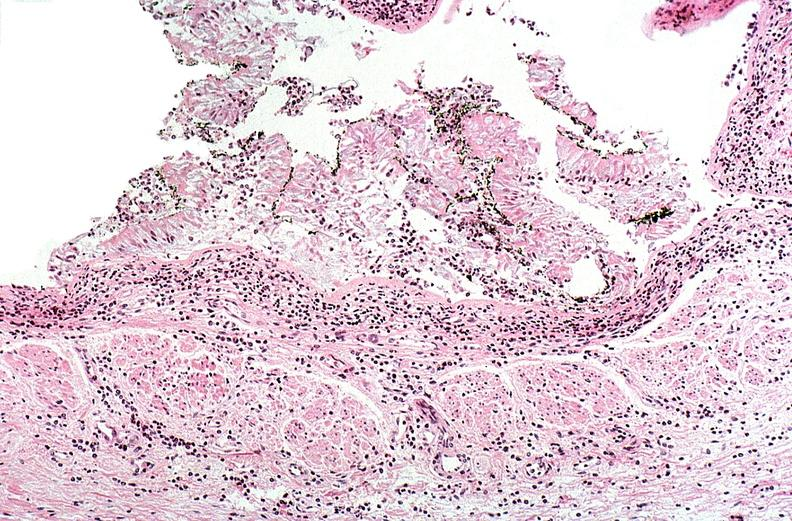where is this?
Answer the question using a single word or phrase. Lung 